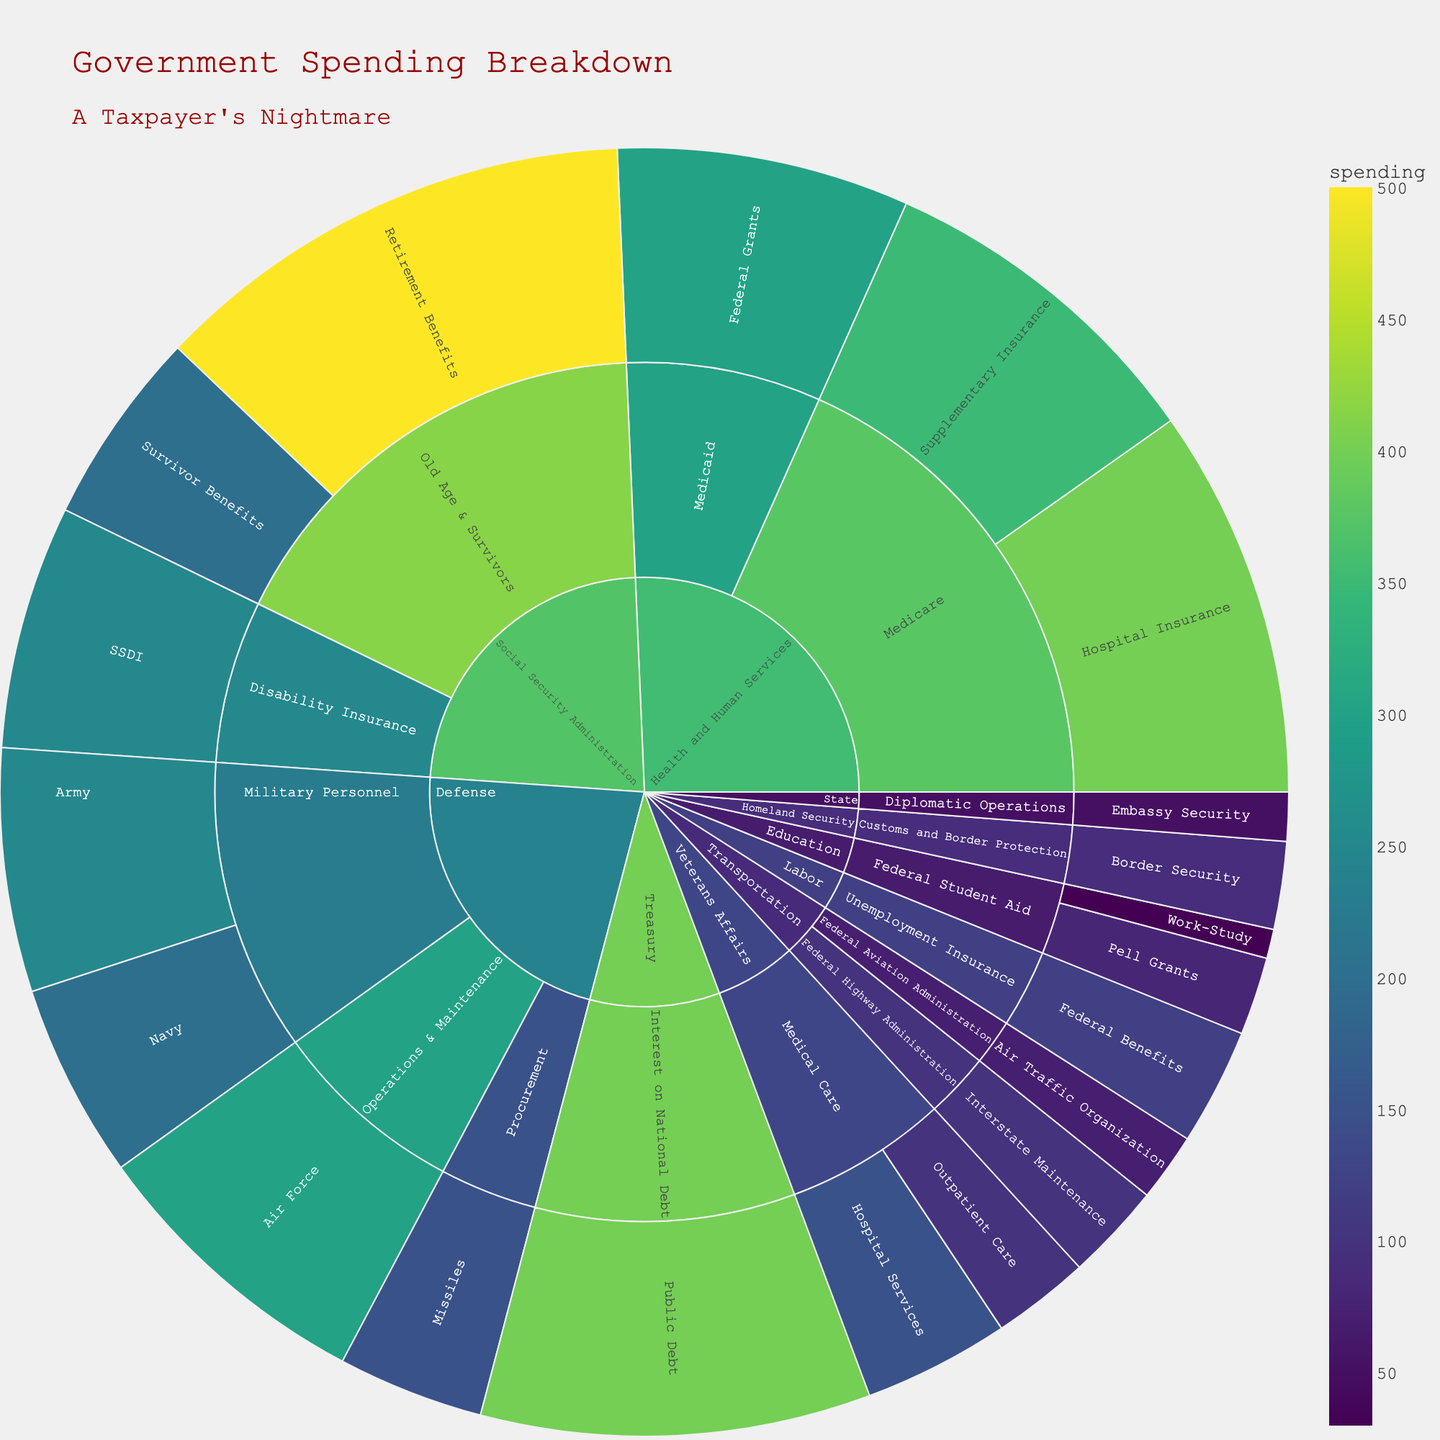What department has the highest spending? The largest colored segment in the sunburst plot represents the department with the highest spending.
Answer: Social Security Administration Which program under the Defense department has the highest spending? Look within the 'Defense' section of the sunburst plot and identify the largest sub-segment.
Answer: Air Force (Operations & Maintenance) How much money is spent on Medicare Hospital Insurance? Locate the 'Health and Human Services' section, then drill down into 'Medicare' and find 'Hospital Insurance'. The spending amount is shown.
Answer: 400 billion What is the combined spending on Medicare Supplementary Insurance and Federal Grants under Medicaid? Add the spending amounts for 'Supplementary Insurance' and 'Federal Grants' in the 'Health and Human Services' section. 350 + 300 = 650
Answer: 650 billion Compare the spending on SSDI (Disability Insurance) to that on Federal Benefits under Unemployment Insurance. Which one is higher? Look at the sizes of the segments for 'SSDI' under 'Social Security Administration' and 'Federal Benefits' under 'Labor'.
Answer: SSDI Which category under the Treasury department has the highest spending? The 'Treasury' section is small and contains the 'Public Debt' segment, which is the only sub-segment and thus the highest.
Answer: Public Debt What is the total spending on Education programs? Add the spending amounts for 'Pell Grants' and 'Work-Study' in the 'Education' section. 80 + 30 = 110
Answer: 110 billion Which department has more programs, Veterans Affairs or Transportation? Count the sub-segments in the 'Veterans Affairs' and 'Transportation' sections.
Answer: Veterans Affairs List the categories and their corresponding spending under the Social Security Administration. Break down the `Social Security Administration` segment into its sub-segments, which are 'Old Age & Survivors' and 'Disability Insurance,' and note their spending volumes.
Answer: Retirement Benefits: 500, Survivor Benefits: 200, SSDI: 250 Is the spending on Public Debt greater than the combined spending on Border Security and Air Traffic Organization? Compare the spending on Public Debt (400) with the sum of Border Security (90) and Air Traffic Organization (70). 90 + 70 = 160, and 400 > 160.
Answer: Yes 